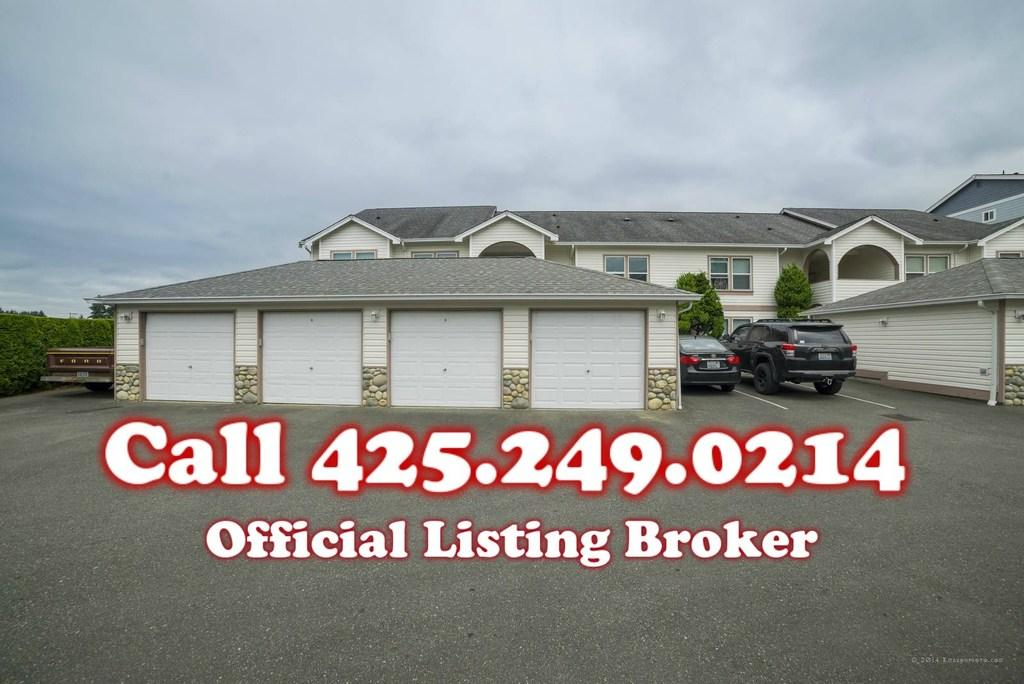What type of structure is visible in the image? There is a house with windows in the image. What vehicles are parked in the image? There are two cars parked in the image. What type of vegetation can be seen in the image? There are trees and small bushes in the image. Can you describe any additional features of the image? There is a watermark on the image. What type of sheet is covering the trees in the image? There is no sheet covering the trees in the image; the trees are visible without any covering. 